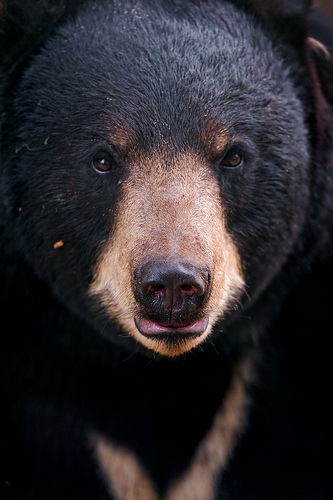Please provide the bounding box coordinate of the region this sentence describes: light brown area on the bears muzzle. The bounding box coordinates for the light brown area on the bear's muzzle are [0.4, 0.3, 0.62, 0.52]. This section includes the light brown fur on the muzzle, contrasting with the darker fur on the rest of the face. 